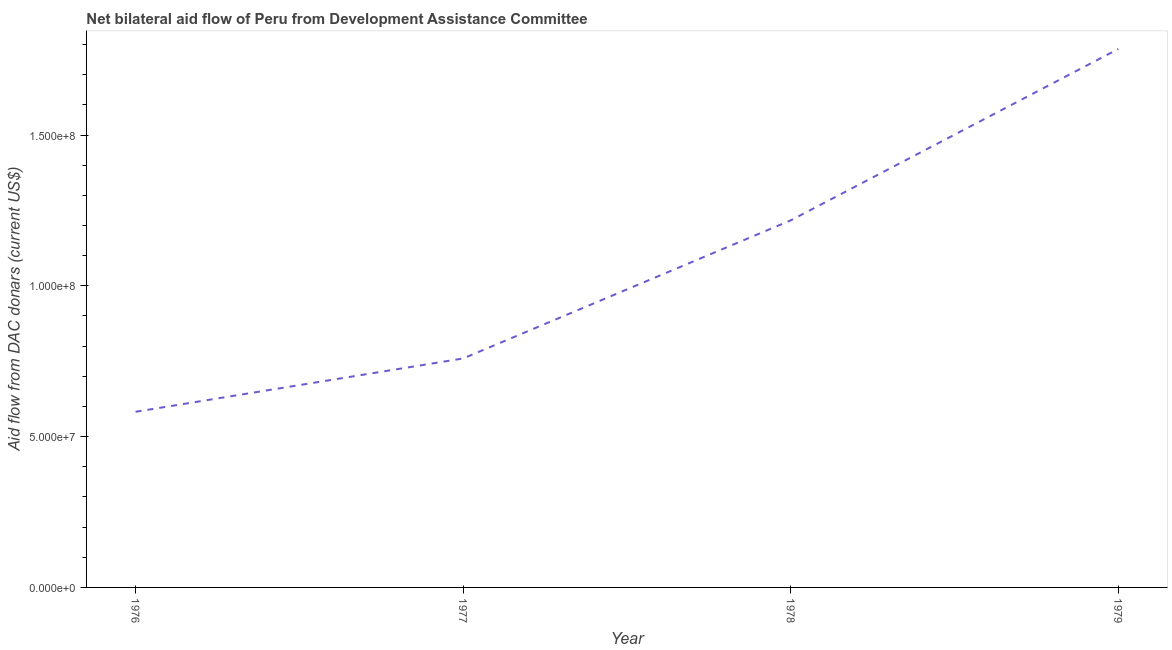What is the net bilateral aid flows from dac donors in 1978?
Provide a short and direct response. 1.22e+08. Across all years, what is the maximum net bilateral aid flows from dac donors?
Offer a terse response. 1.79e+08. Across all years, what is the minimum net bilateral aid flows from dac donors?
Your response must be concise. 5.82e+07. In which year was the net bilateral aid flows from dac donors maximum?
Your answer should be compact. 1979. In which year was the net bilateral aid flows from dac donors minimum?
Ensure brevity in your answer.  1976. What is the sum of the net bilateral aid flows from dac donors?
Ensure brevity in your answer.  4.34e+08. What is the difference between the net bilateral aid flows from dac donors in 1976 and 1979?
Give a very brief answer. -1.20e+08. What is the average net bilateral aid flows from dac donors per year?
Your answer should be compact. 1.09e+08. What is the median net bilateral aid flows from dac donors?
Offer a terse response. 9.88e+07. What is the ratio of the net bilateral aid flows from dac donors in 1976 to that in 1977?
Offer a very short reply. 0.77. What is the difference between the highest and the second highest net bilateral aid flows from dac donors?
Provide a short and direct response. 5.68e+07. Is the sum of the net bilateral aid flows from dac donors in 1977 and 1979 greater than the maximum net bilateral aid flows from dac donors across all years?
Ensure brevity in your answer.  Yes. What is the difference between the highest and the lowest net bilateral aid flows from dac donors?
Ensure brevity in your answer.  1.20e+08. How many years are there in the graph?
Your answer should be very brief. 4. What is the difference between two consecutive major ticks on the Y-axis?
Your response must be concise. 5.00e+07. What is the title of the graph?
Your answer should be very brief. Net bilateral aid flow of Peru from Development Assistance Committee. What is the label or title of the Y-axis?
Your answer should be compact. Aid flow from DAC donars (current US$). What is the Aid flow from DAC donars (current US$) of 1976?
Make the answer very short. 5.82e+07. What is the Aid flow from DAC donars (current US$) of 1977?
Keep it short and to the point. 7.59e+07. What is the Aid flow from DAC donars (current US$) in 1978?
Provide a short and direct response. 1.22e+08. What is the Aid flow from DAC donars (current US$) in 1979?
Offer a very short reply. 1.79e+08. What is the difference between the Aid flow from DAC donars (current US$) in 1976 and 1977?
Offer a terse response. -1.77e+07. What is the difference between the Aid flow from DAC donars (current US$) in 1976 and 1978?
Provide a succinct answer. -6.35e+07. What is the difference between the Aid flow from DAC donars (current US$) in 1976 and 1979?
Ensure brevity in your answer.  -1.20e+08. What is the difference between the Aid flow from DAC donars (current US$) in 1977 and 1978?
Offer a very short reply. -4.58e+07. What is the difference between the Aid flow from DAC donars (current US$) in 1977 and 1979?
Provide a succinct answer. -1.03e+08. What is the difference between the Aid flow from DAC donars (current US$) in 1978 and 1979?
Your answer should be compact. -5.68e+07. What is the ratio of the Aid flow from DAC donars (current US$) in 1976 to that in 1977?
Provide a short and direct response. 0.77. What is the ratio of the Aid flow from DAC donars (current US$) in 1976 to that in 1978?
Provide a short and direct response. 0.48. What is the ratio of the Aid flow from DAC donars (current US$) in 1976 to that in 1979?
Your answer should be very brief. 0.33. What is the ratio of the Aid flow from DAC donars (current US$) in 1977 to that in 1978?
Provide a short and direct response. 0.62. What is the ratio of the Aid flow from DAC donars (current US$) in 1977 to that in 1979?
Ensure brevity in your answer.  0.42. What is the ratio of the Aid flow from DAC donars (current US$) in 1978 to that in 1979?
Give a very brief answer. 0.68. 